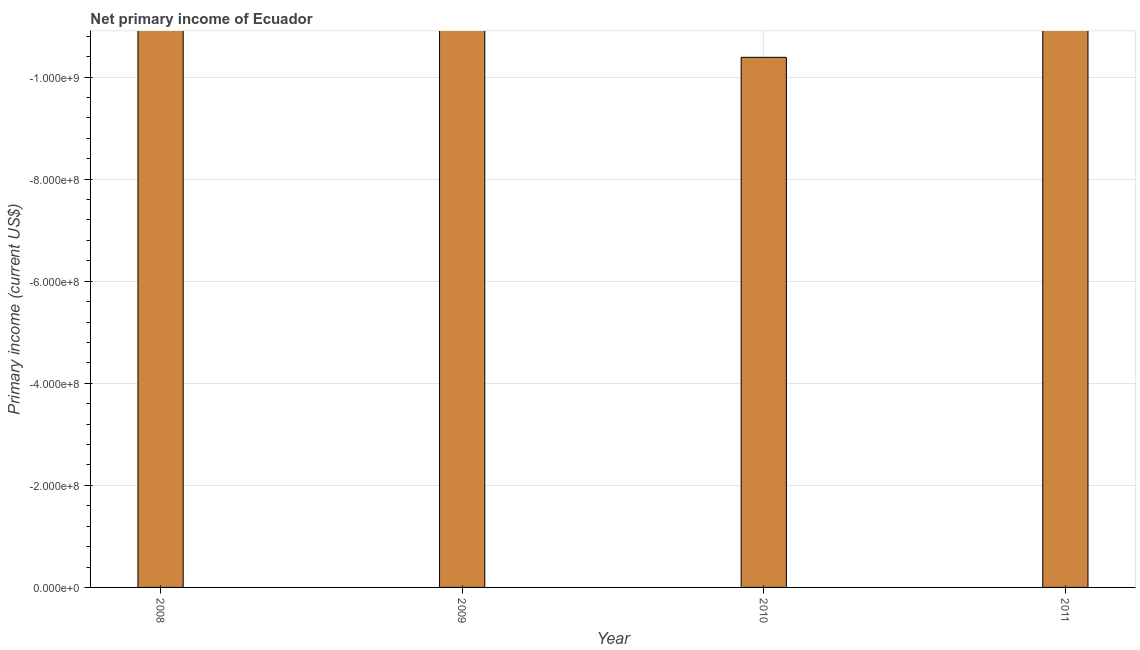Does the graph contain grids?
Your answer should be very brief. Yes. What is the title of the graph?
Your answer should be compact. Net primary income of Ecuador. What is the label or title of the Y-axis?
Offer a terse response. Primary income (current US$). Across all years, what is the minimum amount of primary income?
Your answer should be very brief. 0. What is the sum of the amount of primary income?
Your answer should be very brief. 0. What is the average amount of primary income per year?
Keep it short and to the point. 0. In how many years, is the amount of primary income greater than -440000000 US$?
Your answer should be very brief. 0. In how many years, is the amount of primary income greater than the average amount of primary income taken over all years?
Provide a succinct answer. 0. How many years are there in the graph?
Your answer should be very brief. 4. What is the Primary income (current US$) of 2008?
Provide a short and direct response. 0. What is the Primary income (current US$) of 2010?
Make the answer very short. 0. 